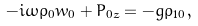Convert formula to latex. <formula><loc_0><loc_0><loc_500><loc_500>- i \omega \rho _ { 0 } w _ { 0 } + P _ { 0 z } = - g \rho _ { 1 0 } \, ,</formula> 